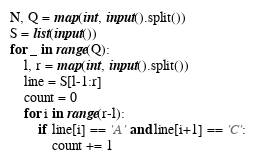<code> <loc_0><loc_0><loc_500><loc_500><_Python_>N, Q = map(int, input().split())
S = list(input())
for _ in range(Q):
    l, r = map(int, input().split())
    line = S[l-1:r]
    count = 0
    for i in range(r-l):
        if line[i] == 'A' and line[i+1] == 'C':
            count += 1
</code> 